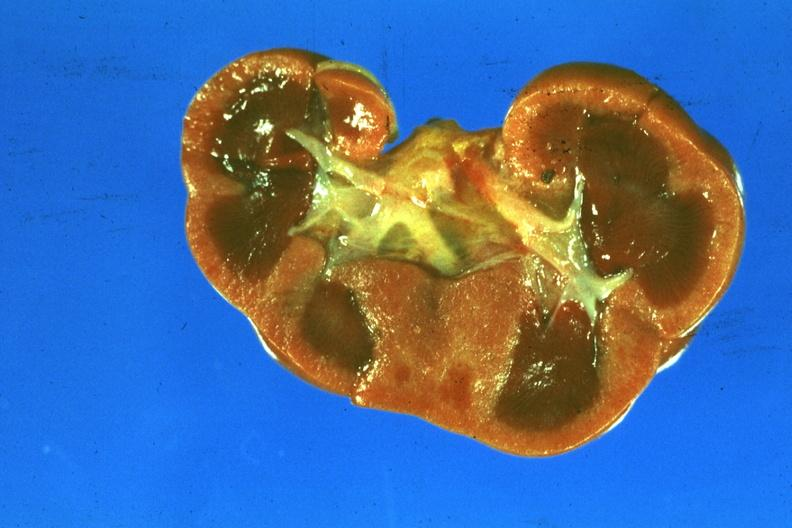s this typical thecoma with yellow foci present?
Answer the question using a single word or phrase. No 